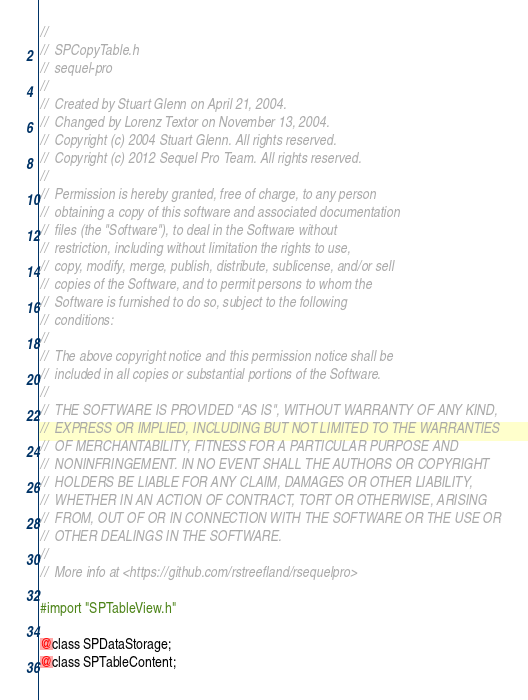<code> <loc_0><loc_0><loc_500><loc_500><_C_>//
//  SPCopyTable.h
//  sequel-pro
//
//  Created by Stuart Glenn on April 21, 2004.
//  Changed by Lorenz Textor on November 13, 2004.
//  Copyright (c) 2004 Stuart Glenn. All rights reserved.
//  Copyright (c) 2012 Sequel Pro Team. All rights reserved.
//
//  Permission is hereby granted, free of charge, to any person
//  obtaining a copy of this software and associated documentation
//  files (the "Software"), to deal in the Software without
//  restriction, including without limitation the rights to use,
//  copy, modify, merge, publish, distribute, sublicense, and/or sell
//  copies of the Software, and to permit persons to whom the
//  Software is furnished to do so, subject to the following
//  conditions:
//
//  The above copyright notice and this permission notice shall be
//  included in all copies or substantial portions of the Software.
//
//  THE SOFTWARE IS PROVIDED "AS IS", WITHOUT WARRANTY OF ANY KIND,
//  EXPRESS OR IMPLIED, INCLUDING BUT NOT LIMITED TO THE WARRANTIES
//  OF MERCHANTABILITY, FITNESS FOR A PARTICULAR PURPOSE AND
//  NONINFRINGEMENT. IN NO EVENT SHALL THE AUTHORS OR COPYRIGHT
//  HOLDERS BE LIABLE FOR ANY CLAIM, DAMAGES OR OTHER LIABILITY,
//  WHETHER IN AN ACTION OF CONTRACT, TORT OR OTHERWISE, ARISING
//  FROM, OUT OF OR IN CONNECTION WITH THE SOFTWARE OR THE USE OR
//  OTHER DEALINGS IN THE SOFTWARE.
//
//  More info at <https://github.com/rstreefland/rsequelpro>

#import "SPTableView.h"

@class SPDataStorage;
@class SPTableContent;
</code> 